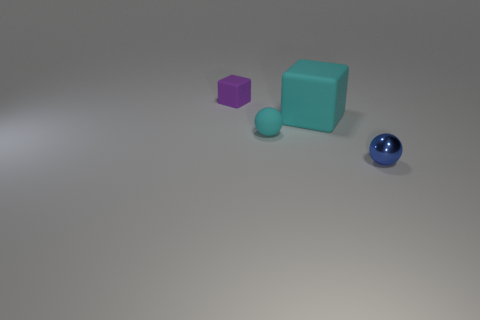Is there any other thing that has the same size as the cyan rubber cube?
Make the answer very short. No. There is a cyan matte thing behind the cyan ball; is its size the same as the rubber sphere?
Your answer should be compact. No. What number of purple cylinders are there?
Give a very brief answer. 0. What number of objects are both behind the small cyan sphere and on the right side of the cyan ball?
Ensure brevity in your answer.  1. Is there another tiny object that has the same material as the blue thing?
Provide a succinct answer. No. There is a small blue sphere in front of the small rubber thing that is behind the cyan matte sphere; what is its material?
Provide a succinct answer. Metal. Are there the same number of cyan objects that are on the left side of the large cyan rubber object and cyan objects behind the blue metal thing?
Your answer should be very brief. No. Do the purple thing and the large cyan object have the same shape?
Make the answer very short. Yes. There is a object that is to the right of the cyan rubber sphere and in front of the large cyan matte block; what is its material?
Offer a terse response. Metal. What number of other things have the same shape as the big thing?
Offer a very short reply. 1. 